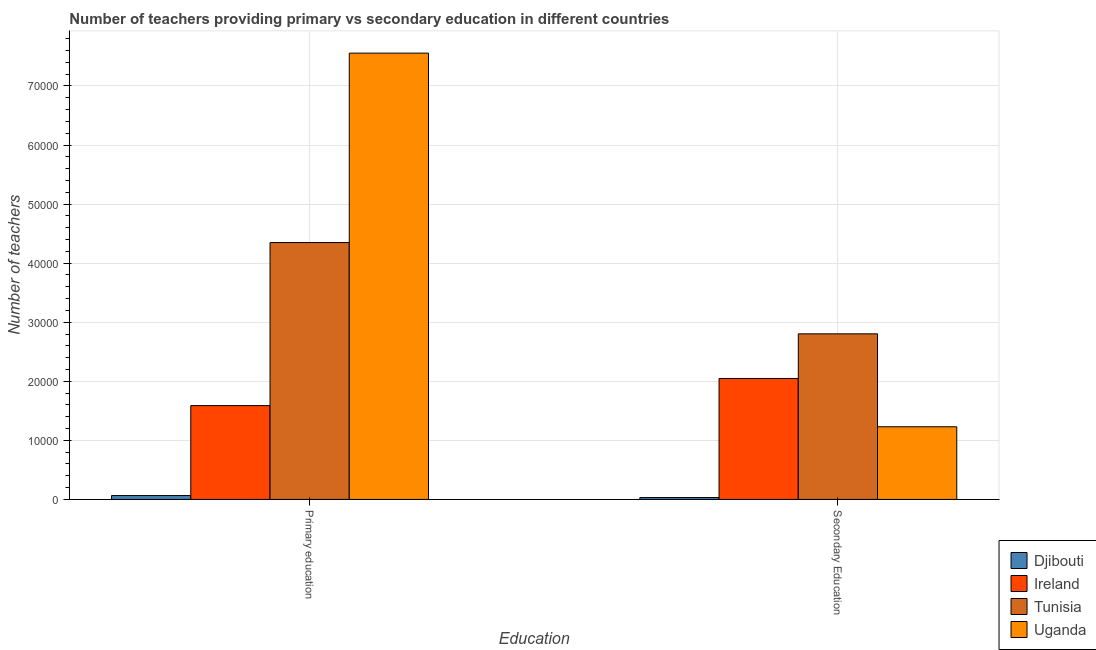How many different coloured bars are there?
Provide a succinct answer. 4. Are the number of bars per tick equal to the number of legend labels?
Ensure brevity in your answer.  Yes. How many bars are there on the 2nd tick from the right?
Ensure brevity in your answer.  4. What is the number of primary teachers in Ireland?
Make the answer very short. 1.59e+04. Across all countries, what is the maximum number of secondary teachers?
Offer a terse response. 2.80e+04. Across all countries, what is the minimum number of secondary teachers?
Make the answer very short. 320. In which country was the number of primary teachers maximum?
Make the answer very short. Uganda. In which country was the number of secondary teachers minimum?
Offer a very short reply. Djibouti. What is the total number of primary teachers in the graph?
Give a very brief answer. 1.36e+05. What is the difference between the number of secondary teachers in Tunisia and that in Djibouti?
Ensure brevity in your answer.  2.77e+04. What is the difference between the number of primary teachers in Ireland and the number of secondary teachers in Djibouti?
Provide a short and direct response. 1.56e+04. What is the average number of secondary teachers per country?
Your answer should be very brief. 1.53e+04. What is the difference between the number of primary teachers and number of secondary teachers in Uganda?
Offer a very short reply. 6.33e+04. What is the ratio of the number of primary teachers in Ireland to that in Uganda?
Your response must be concise. 0.21. Is the number of secondary teachers in Djibouti less than that in Ireland?
Give a very brief answer. Yes. In how many countries, is the number of primary teachers greater than the average number of primary teachers taken over all countries?
Your response must be concise. 2. What does the 1st bar from the left in Primary education represents?
Offer a terse response. Djibouti. What does the 4th bar from the right in Primary education represents?
Offer a terse response. Djibouti. Are all the bars in the graph horizontal?
Your answer should be compact. No. How many countries are there in the graph?
Your answer should be very brief. 4. What is the difference between two consecutive major ticks on the Y-axis?
Your answer should be very brief. 10000. Are the values on the major ticks of Y-axis written in scientific E-notation?
Your response must be concise. No. Does the graph contain grids?
Provide a short and direct response. Yes. What is the title of the graph?
Your answer should be very brief. Number of teachers providing primary vs secondary education in different countries. What is the label or title of the X-axis?
Your answer should be compact. Education. What is the label or title of the Y-axis?
Your answer should be compact. Number of teachers. What is the Number of teachers in Djibouti in Primary education?
Provide a short and direct response. 655. What is the Number of teachers of Ireland in Primary education?
Provide a short and direct response. 1.59e+04. What is the Number of teachers in Tunisia in Primary education?
Ensure brevity in your answer.  4.35e+04. What is the Number of teachers of Uganda in Primary education?
Your response must be concise. 7.56e+04. What is the Number of teachers in Djibouti in Secondary Education?
Keep it short and to the point. 320. What is the Number of teachers of Ireland in Secondary Education?
Keep it short and to the point. 2.05e+04. What is the Number of teachers of Tunisia in Secondary Education?
Provide a succinct answer. 2.80e+04. What is the Number of teachers of Uganda in Secondary Education?
Make the answer very short. 1.23e+04. Across all Education, what is the maximum Number of teachers in Djibouti?
Offer a terse response. 655. Across all Education, what is the maximum Number of teachers in Ireland?
Make the answer very short. 2.05e+04. Across all Education, what is the maximum Number of teachers in Tunisia?
Ensure brevity in your answer.  4.35e+04. Across all Education, what is the maximum Number of teachers of Uganda?
Ensure brevity in your answer.  7.56e+04. Across all Education, what is the minimum Number of teachers in Djibouti?
Ensure brevity in your answer.  320. Across all Education, what is the minimum Number of teachers in Ireland?
Your answer should be compact. 1.59e+04. Across all Education, what is the minimum Number of teachers in Tunisia?
Offer a very short reply. 2.80e+04. Across all Education, what is the minimum Number of teachers of Uganda?
Make the answer very short. 1.23e+04. What is the total Number of teachers of Djibouti in the graph?
Your response must be concise. 975. What is the total Number of teachers in Ireland in the graph?
Offer a very short reply. 3.64e+04. What is the total Number of teachers of Tunisia in the graph?
Provide a succinct answer. 7.15e+04. What is the total Number of teachers in Uganda in the graph?
Give a very brief answer. 8.79e+04. What is the difference between the Number of teachers in Djibouti in Primary education and that in Secondary Education?
Provide a short and direct response. 335. What is the difference between the Number of teachers of Ireland in Primary education and that in Secondary Education?
Your response must be concise. -4595. What is the difference between the Number of teachers of Tunisia in Primary education and that in Secondary Education?
Offer a very short reply. 1.55e+04. What is the difference between the Number of teachers of Uganda in Primary education and that in Secondary Education?
Keep it short and to the point. 6.33e+04. What is the difference between the Number of teachers in Djibouti in Primary education and the Number of teachers in Ireland in Secondary Education?
Make the answer very short. -1.98e+04. What is the difference between the Number of teachers of Djibouti in Primary education and the Number of teachers of Tunisia in Secondary Education?
Your response must be concise. -2.74e+04. What is the difference between the Number of teachers of Djibouti in Primary education and the Number of teachers of Uganda in Secondary Education?
Provide a short and direct response. -1.16e+04. What is the difference between the Number of teachers of Ireland in Primary education and the Number of teachers of Tunisia in Secondary Education?
Your response must be concise. -1.22e+04. What is the difference between the Number of teachers in Ireland in Primary education and the Number of teachers in Uganda in Secondary Education?
Offer a very short reply. 3580. What is the difference between the Number of teachers of Tunisia in Primary education and the Number of teachers of Uganda in Secondary Education?
Your response must be concise. 3.12e+04. What is the average Number of teachers in Djibouti per Education?
Provide a short and direct response. 487.5. What is the average Number of teachers in Ireland per Education?
Ensure brevity in your answer.  1.82e+04. What is the average Number of teachers of Tunisia per Education?
Your response must be concise. 3.58e+04. What is the average Number of teachers of Uganda per Education?
Make the answer very short. 4.39e+04. What is the difference between the Number of teachers in Djibouti and Number of teachers in Ireland in Primary education?
Offer a very short reply. -1.52e+04. What is the difference between the Number of teachers in Djibouti and Number of teachers in Tunisia in Primary education?
Your answer should be very brief. -4.28e+04. What is the difference between the Number of teachers in Djibouti and Number of teachers in Uganda in Primary education?
Your answer should be very brief. -7.49e+04. What is the difference between the Number of teachers of Ireland and Number of teachers of Tunisia in Primary education?
Provide a short and direct response. -2.76e+04. What is the difference between the Number of teachers in Ireland and Number of teachers in Uganda in Primary education?
Make the answer very short. -5.97e+04. What is the difference between the Number of teachers in Tunisia and Number of teachers in Uganda in Primary education?
Provide a short and direct response. -3.21e+04. What is the difference between the Number of teachers of Djibouti and Number of teachers of Ireland in Secondary Education?
Ensure brevity in your answer.  -2.02e+04. What is the difference between the Number of teachers of Djibouti and Number of teachers of Tunisia in Secondary Education?
Provide a short and direct response. -2.77e+04. What is the difference between the Number of teachers in Djibouti and Number of teachers in Uganda in Secondary Education?
Make the answer very short. -1.20e+04. What is the difference between the Number of teachers of Ireland and Number of teachers of Tunisia in Secondary Education?
Your answer should be very brief. -7561. What is the difference between the Number of teachers of Ireland and Number of teachers of Uganda in Secondary Education?
Give a very brief answer. 8175. What is the difference between the Number of teachers in Tunisia and Number of teachers in Uganda in Secondary Education?
Your answer should be compact. 1.57e+04. What is the ratio of the Number of teachers in Djibouti in Primary education to that in Secondary Education?
Keep it short and to the point. 2.05. What is the ratio of the Number of teachers of Ireland in Primary education to that in Secondary Education?
Offer a terse response. 0.78. What is the ratio of the Number of teachers in Tunisia in Primary education to that in Secondary Education?
Make the answer very short. 1.55. What is the ratio of the Number of teachers of Uganda in Primary education to that in Secondary Education?
Provide a short and direct response. 6.14. What is the difference between the highest and the second highest Number of teachers in Djibouti?
Keep it short and to the point. 335. What is the difference between the highest and the second highest Number of teachers in Ireland?
Ensure brevity in your answer.  4595. What is the difference between the highest and the second highest Number of teachers of Tunisia?
Provide a short and direct response. 1.55e+04. What is the difference between the highest and the second highest Number of teachers of Uganda?
Give a very brief answer. 6.33e+04. What is the difference between the highest and the lowest Number of teachers in Djibouti?
Your response must be concise. 335. What is the difference between the highest and the lowest Number of teachers of Ireland?
Your answer should be compact. 4595. What is the difference between the highest and the lowest Number of teachers of Tunisia?
Your answer should be compact. 1.55e+04. What is the difference between the highest and the lowest Number of teachers of Uganda?
Give a very brief answer. 6.33e+04. 